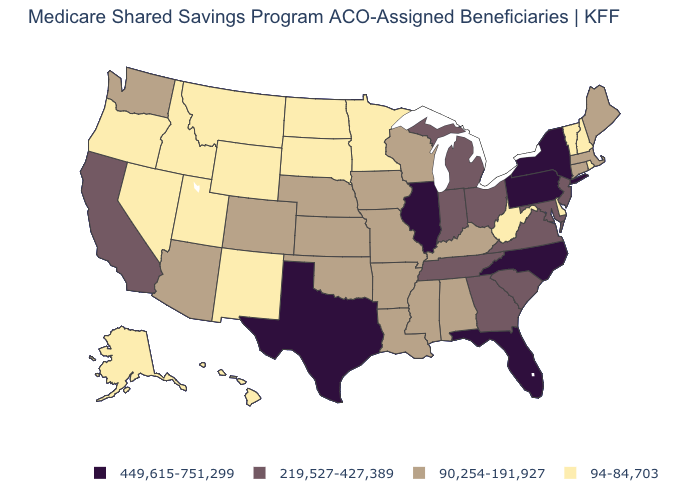Among the states that border Florida , does Georgia have the lowest value?
Quick response, please. No. Does the first symbol in the legend represent the smallest category?
Answer briefly. No. What is the value of New Mexico?
Be succinct. 94-84,703. Name the states that have a value in the range 90,254-191,927?
Be succinct. Alabama, Arizona, Arkansas, Colorado, Connecticut, Iowa, Kansas, Kentucky, Louisiana, Maine, Massachusetts, Mississippi, Missouri, Nebraska, Oklahoma, Washington, Wisconsin. What is the highest value in states that border California?
Quick response, please. 90,254-191,927. Among the states that border Louisiana , does Mississippi have the lowest value?
Quick response, please. Yes. What is the value of Arizona?
Answer briefly. 90,254-191,927. Name the states that have a value in the range 219,527-427,389?
Answer briefly. California, Georgia, Indiana, Maryland, Michigan, New Jersey, Ohio, South Carolina, Tennessee, Virginia. Which states have the lowest value in the South?
Give a very brief answer. Delaware, West Virginia. What is the highest value in states that border West Virginia?
Keep it brief. 449,615-751,299. Does the first symbol in the legend represent the smallest category?
Short answer required. No. Name the states that have a value in the range 449,615-751,299?
Short answer required. Florida, Illinois, New York, North Carolina, Pennsylvania, Texas. Name the states that have a value in the range 90,254-191,927?
Keep it brief. Alabama, Arizona, Arkansas, Colorado, Connecticut, Iowa, Kansas, Kentucky, Louisiana, Maine, Massachusetts, Mississippi, Missouri, Nebraska, Oklahoma, Washington, Wisconsin. Which states have the highest value in the USA?
Short answer required. Florida, Illinois, New York, North Carolina, Pennsylvania, Texas. What is the value of Utah?
Answer briefly. 94-84,703. 